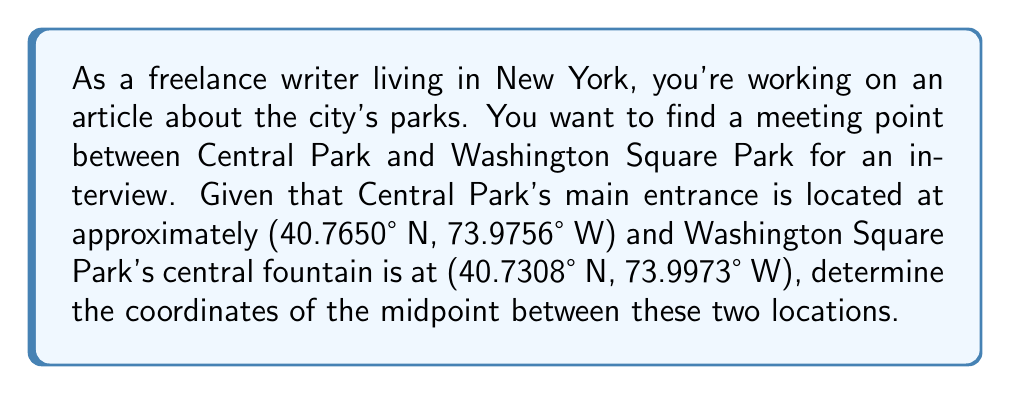Show me your answer to this math problem. To solve this problem, we'll use the midpoint formula in two dimensions. The midpoint formula is:

$$ \text{Midpoint} = \left(\frac{x_1 + x_2}{2}, \frac{y_1 + y_2}{2}\right) $$

Where $(x_1, y_1)$ are the coordinates of the first point and $(x_2, y_2)$ are the coordinates of the second point.

Let's assign our points:
Central Park (Point 1): $(x_1, y_1) = (40.7650, -73.9756)$
Washington Square Park (Point 2): $(x_2, y_2) = (40.7308, -73.9973)$

Note that we use negative values for the western longitude.

Now, let's apply the midpoint formula:

$$ x_{\text{midpoint}} = \frac{x_1 + x_2}{2} = \frac{40.7650 + 40.7308}{2} = \frac{81.4958}{2} = 40.7479 $$

$$ y_{\text{midpoint}} = \frac{y_1 + y_2}{2} = \frac{-73.9756 + (-73.9973)}{2} = \frac{-147.9729}{2} = -73.98645 $$

Therefore, the midpoint coordinates are (40.7479° N, 73.98645° W).

[asy]
import geometry;

real xscale = 100;
real yscale = 500;

pair CP = (40.7650, -73.9756);
pair WSP = (40.7308, -73.9973);
pair MP = ((CP.x + WSP.x)/2, (CP.y + WSP.y)/2);

draw((40.72, -74) -- (40.77, -73.97), gray);
dot(CP, red);
dot(WSP, blue);
dot(MP, green);

label("Central Park", CP, N, red);
label("Washington Square Park", WSP, S, blue);
label("Midpoint", MP, E, green);

xaxis("Latitude", BottomTop, LeftTicks);
yaxis("Longitude", LeftRight, RightTicks);
[/asy]
Answer: The coordinates of the midpoint between Central Park and Washington Square Park are approximately (40.7479° N, 73.98645° W). 